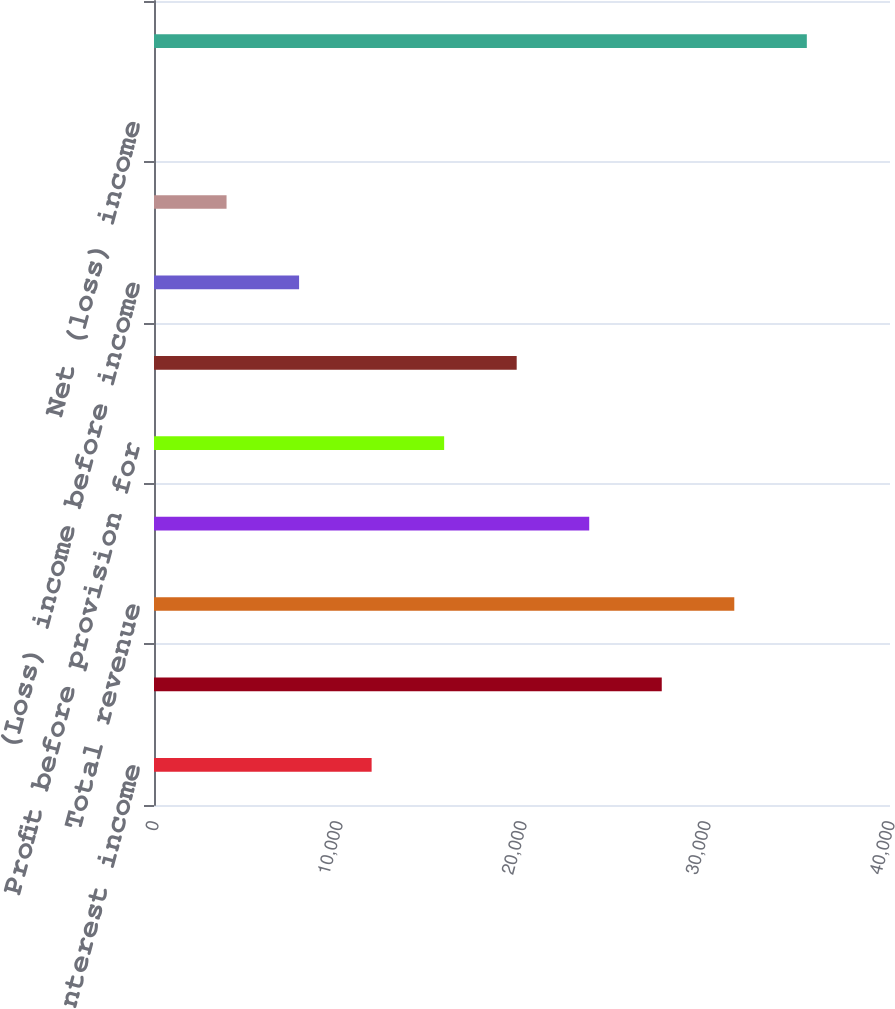<chart> <loc_0><loc_0><loc_500><loc_500><bar_chart><fcel>Net interest income<fcel>Noninterest income<fcel>Total revenue<fcel>Noninterest expense<fcel>Profit before provision for<fcel>Provision for credit losses<fcel>(Loss) income before income<fcel>Income tax (benefit) expense<fcel>Net (loss) income<fcel>Loans and leases and loans<nl><fcel>11827.3<fcel>27595.7<fcel>31537.8<fcel>23653.6<fcel>15769.4<fcel>19711.5<fcel>7885.2<fcel>3943.1<fcel>1<fcel>35479.9<nl></chart> 